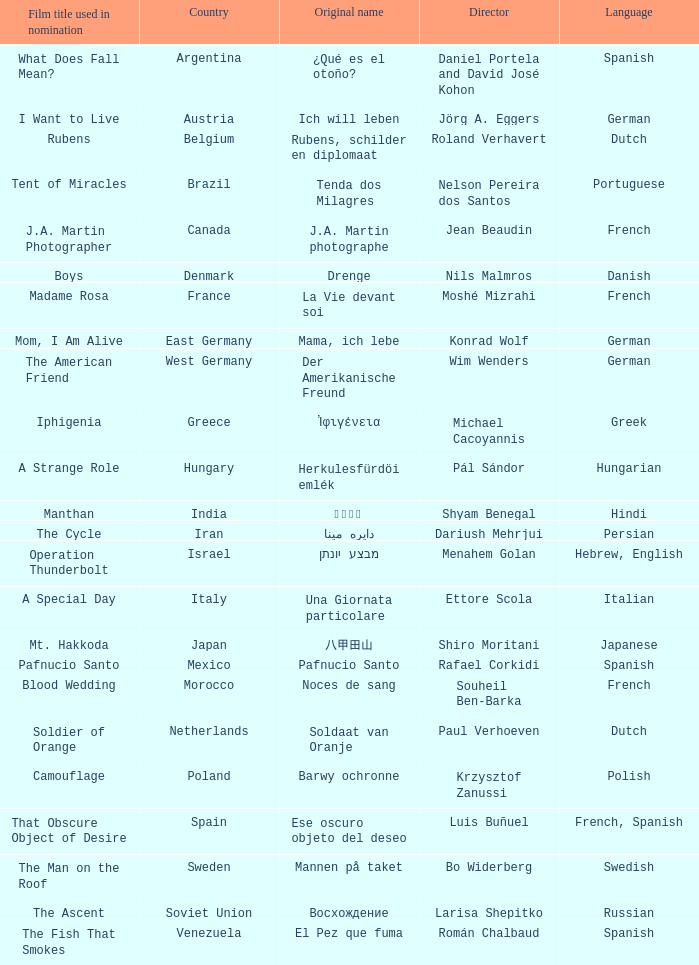Which country is the director Roland Verhavert from? Belgium. 